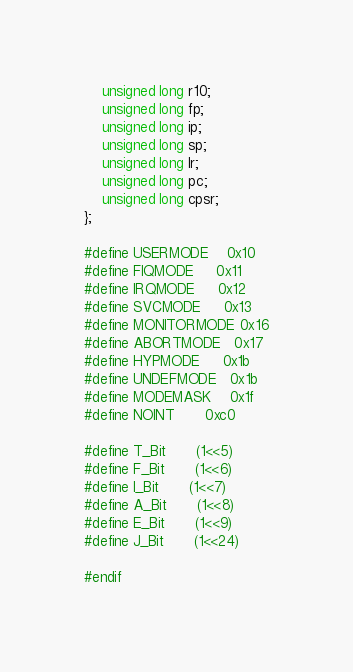<code> <loc_0><loc_0><loc_500><loc_500><_C_>    unsigned long r10;
    unsigned long fp;
    unsigned long ip;
    unsigned long sp;
    unsigned long lr;
    unsigned long pc;
    unsigned long cpsr;
};

#define USERMODE    0x10
#define FIQMODE     0x11
#define IRQMODE     0x12
#define SVCMODE     0x13
#define MONITORMODE 0x16
#define ABORTMODE   0x17
#define HYPMODE     0x1b
#define UNDEFMODE   0x1b
#define MODEMASK    0x1f
#define NOINT       0xc0

#define T_Bit       (1<<5)
#define F_Bit       (1<<6)
#define I_Bit       (1<<7)
#define A_Bit       (1<<8)
#define E_Bit       (1<<9)
#define J_Bit       (1<<24)

#endif
</code> 